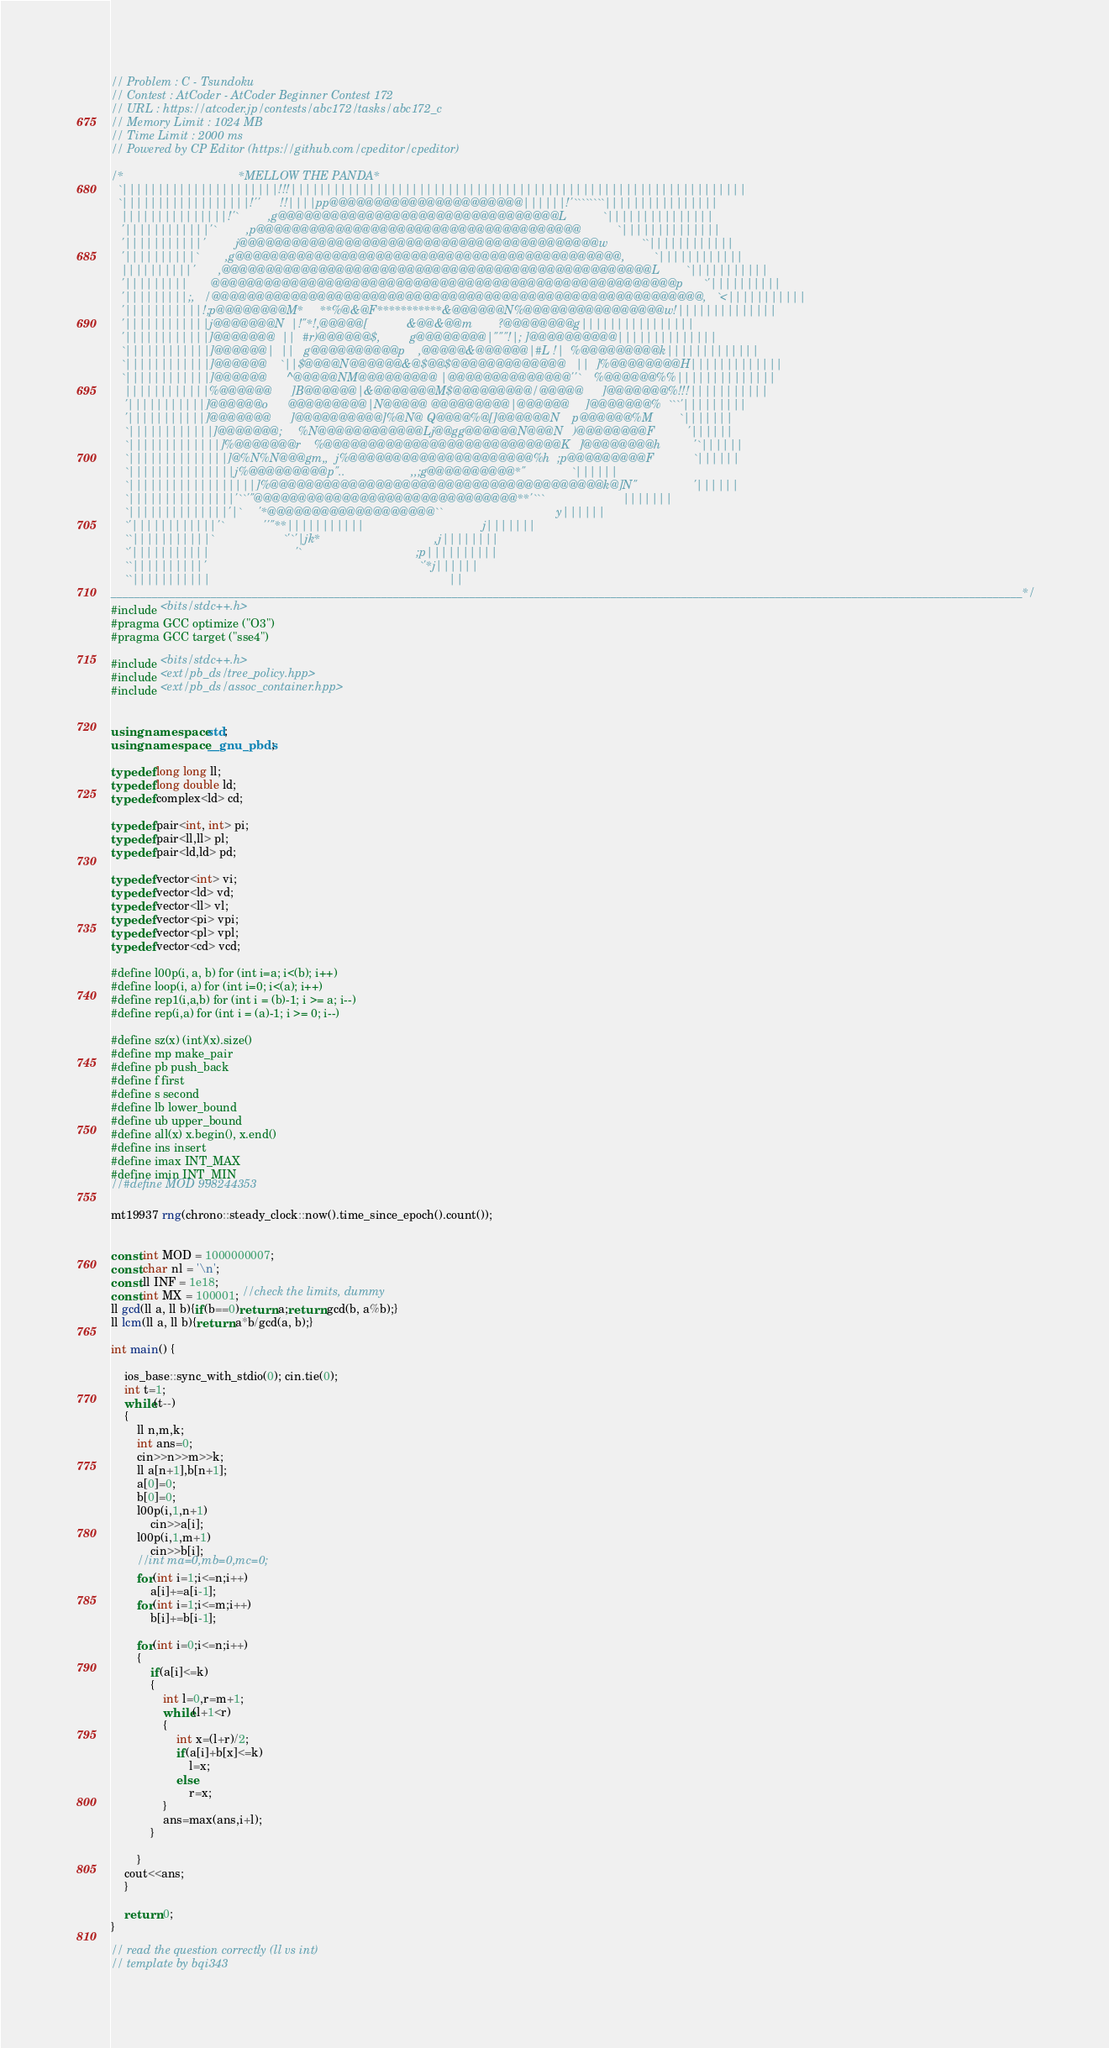Convert code to text. <code><loc_0><loc_0><loc_500><loc_500><_C++_>
// Problem : C - Tsundoku
// Contest : AtCoder - AtCoder Beginner Contest 172
// URL : https://atcoder.jp/contests/abc172/tasks/abc172_c
// Memory Limit : 1024 MB
// Time Limit : 2000 ms
// Powered by CP Editor (https://github.com/cpeditor/cpeditor)

/*                                   *MELLOW THE PANDA*
  `||||||||||||||||||||||!!!||||||||||||||||||||||||||||||||||||||||||||||||||||||||||||||||
  `||||||||||||||||||!''      !!||||pp@@@@@@@@@@@@@@@@@@@@@@||||||!'````````||||||||||||||||
   |||||||||||||||!'`         ,g@@@@@@@@@@@@@@@@@@@@@@@@@@@@@@@@L           `|||||||||||||||
   '||||||||||||'`         ,p@@@@@@@@@@@@@@@@@@@@@@@@@@@@@@@@@@@@@           `||||||||||||||
   '|||||||||||'         j@@@@@@@@@@@@@@@@@@@@@@@@@@@@@@@@@@@@@@@@@w          ``||||||||||||
   '||||||||||`        ,g@@@@@@@@@@@@@@@@@@@@@@@@@@@@@@@@@@@@@@@@@@@@,         `||||||||||||
   ||||||||||'       ,@@@@@@@@@@@@@@@@@@@@@@@@@@@@@@@@@@@@@@@@@@@@@@@@@L        `|||||||||||
   '|||||||||       @@@@@@@@@@@@@@@@@@@@@@@@@@@@@@@@@@@@@@@@@@@@@@@@@@@@@p      `'||||||||||
   '|||||||||;,   /@@@@@@@@@@@@@@@@@@@@@@@@@@@@@@@@@@@@@@@@@@@@@@@@@@@@@@@@,   `<|||||||||||
   '|||||||||||!;p@@@@@@@@M*     **%@&@F***********&@@@@@@N%@@@@@@@@@@@@@@@@w!||||||||||||||
   '||||||||||||j@@@@@@@N  |!"*!,@@@@@[            &@@&@@m        ?@@@@@@@@g||||||||||||||||
   '||||||||||||]@@@@@@@  ||  #r)@@@@@@$,         g@@@@@@@@|"""!|; ]@@@@@@@@@@||||||||||||||
   `||||||||||||]@@@@@@|  ||   g@@@@@@@@@@p    ,@@@@@&@@@@@@|#L !|  %@@@@@@@@@k|||||||||||||
   `||||||||||||]@@@@@@    `||$@@@@N@@@@@@&@$@@$@@@@@@@@@@@@@   ||  ]%@@@@@@@@H|||||||||||||
   `||||||||||||]@@@@@@      ^@@@@@NM@@@@@@@@@ |@@@@@@@@@@@@@@''`    %@@@@@@%%||||||||||||||
    ||||||||||||%@@@@@@      ]B@@@@@@|&@@@@@@@M$@@@@@@@@@/@@@@@      ]@@@@@@@%!!!|||||||||||
    '|||||||||||]@@@@@@o      @@@@@@@@@|N@@@@@ @@@@@@@@@|@@@@@@     ]@@@@@@@%  ```'|||||||||
    '|||||||||||]@@@@@@@      ]@@@@@@@@@@]%@N@ Q@@@@%@[]@@@@@@N    p@@@@@@%M        `|||||||
    `||||||||||||]@@@@@@@;     %N@@@@@@@@@@@@Lj@@gg@@@@@@N@@@N   )@@@@@@@@F          '||||||
    `|||||||||||||]%@@@@@@@r    %@@@@@@@@@@@@@@@@@@@@@@@@@@@K   ]@@@@@@@@h          '`||||||
    `||||||||||||||]@%N%N@@@gm,,  j%@@@@@@@@@@@@@@@@@@@@@%h  ;p@@@@@@@@@F            `||||||
    `|||||||||||||||j%@@@@@@@@@p"..                    ,,;g@@@@@@@@@@*"              `||||||
    `||||||||||||||||||]%@@@@@@@@@@@@@@@@@@@@@@@@@@@@@@@@@@@@@@k@]N"                 '||||||
    `|||||||||||||||'``'"@@@@@@@@@@@@@@@@@@@@@@@@@@@@@@**'```                        |||||||
    `||||||||||||||'|`     '*@@@@@@@@@@@@@@@@@@@``                                   y||||||
    `'||||||||||||'`            ''"**|||||||||||                                    j|||||||
    ``|||||||||||`                     `'`'|jk*                                   ,j||||||||
    `'|||||||||||                          '`                                   ;p||||||||||
    ``||||||||||'                                                                 `'*j||||||
    ``|||||||||||                                    						              ||
___________________________________________________________________________________________________________________________________________________________*/
#include <bits/stdc++.h> 
#pragma GCC optimize ("O3")
#pragma GCC target ("sse4")
 
#include <bits/stdc++.h>
#include <ext/pb_ds/tree_policy.hpp>
#include <ext/pb_ds/assoc_container.hpp>
 
 
using namespace std;
using namespace __gnu_pbds;
 
typedef long long ll;
typedef long double ld;
typedef complex<ld> cd;
 
typedef pair<int, int> pi;
typedef pair<ll,ll> pl;
typedef pair<ld,ld> pd;
 
typedef vector<int> vi;
typedef vector<ld> vd;
typedef vector<ll> vl;
typedef vector<pi> vpi;
typedef vector<pl> vpl;
typedef vector<cd> vcd;
 
#define l00p(i, a, b) for (int i=a; i<(b); i++)
#define loop(i, a) for (int i=0; i<(a); i++)
#define rep1(i,a,b) for (int i = (b)-1; i >= a; i--)
#define rep(i,a) for (int i = (a)-1; i >= 0; i--)
 
#define sz(x) (int)(x).size()
#define mp make_pair
#define pb push_back
#define f first
#define s second
#define lb lower_bound
#define ub upper_bound
#define all(x) x.begin(), x.end()
#define ins insert
#define imax INT_MAX
#define imin INT_MIN
//#define MOD 998244353
 
mt19937 rng(chrono::steady_clock::now().time_since_epoch().count());

 
const int MOD = 1000000007;
const char nl = '\n';
const ll INF = 1e18;
const int MX = 100001; //check the limits, dummy
ll gcd(ll a, ll b){if(b==0)return a;return gcd(b, a%b);}
ll lcm(ll a, ll b){return a*b/gcd(a, b);}

int main() {
	 
	ios_base::sync_with_stdio(0); cin.tie(0); 
	int t=1;
	while(t--)
	{
		ll n,m,k;
		int ans=0;
		cin>>n>>m>>k;
		ll a[n+1],b[n+1];
		a[0]=0;
		b[0]=0;
		l00p(i,1,n+1)
			cin>>a[i];
		l00p(i,1,m+1)
			cin>>b[i];
		//int ma=0,mb=0,mc=0;
		for(int i=1;i<=n;i++)
			a[i]+=a[i-1];
		for(int i=1;i<=m;i++)
			b[i]+=b[i-1];
		
		for(int i=0;i<=n;i++)
		{
			if(a[i]<=k)
			{
				int l=0,r=m+1;
				while(l+1<r)
				{
					int x=(l+r)/2;
					if(a[i]+b[x]<=k)
						l=x;
					else
						r=x;
				}
				ans=max(ans,i+l);
			}
			
		}
    cout<<ans;
    }
    
	return 0;
}
 
// read the question correctly (ll vs int)
// template by bqi343</code> 